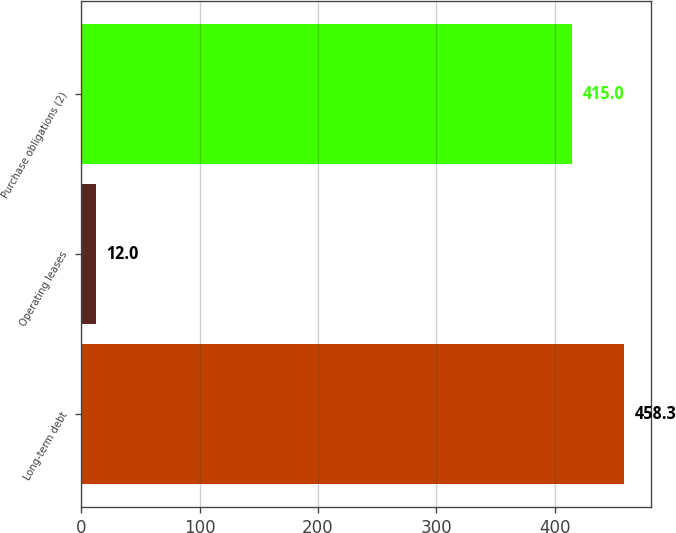Convert chart to OTSL. <chart><loc_0><loc_0><loc_500><loc_500><bar_chart><fcel>Long-term debt<fcel>Operating leases<fcel>Purchase obligations (2)<nl><fcel>458.3<fcel>12<fcel>415<nl></chart> 